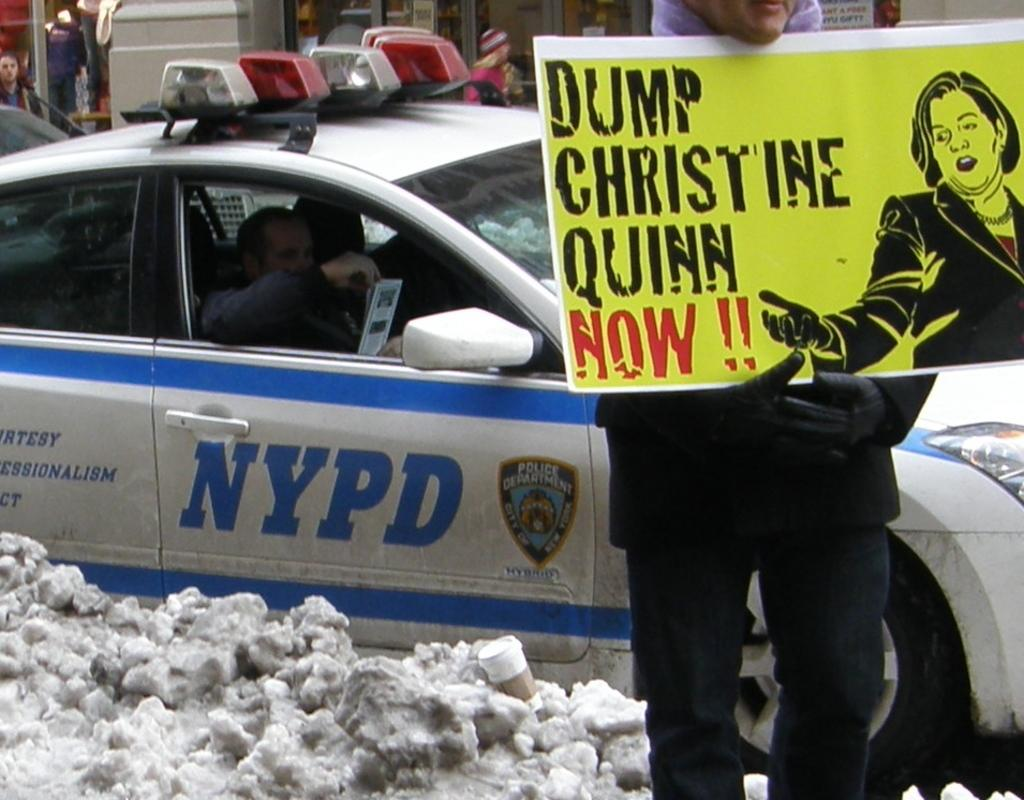What is the person in the image doing? The person is holding a note in the image. What else can be seen in the image besides the person? There is a car and snow on the floor in the image. What type of guitar is the person playing in the image? There is no guitar present in the image; the person is holding a note and standing near a car in the snow. 